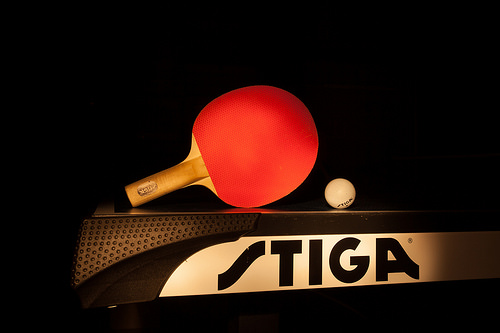<image>
Is the ball above the table? No. The ball is not positioned above the table. The vertical arrangement shows a different relationship. 